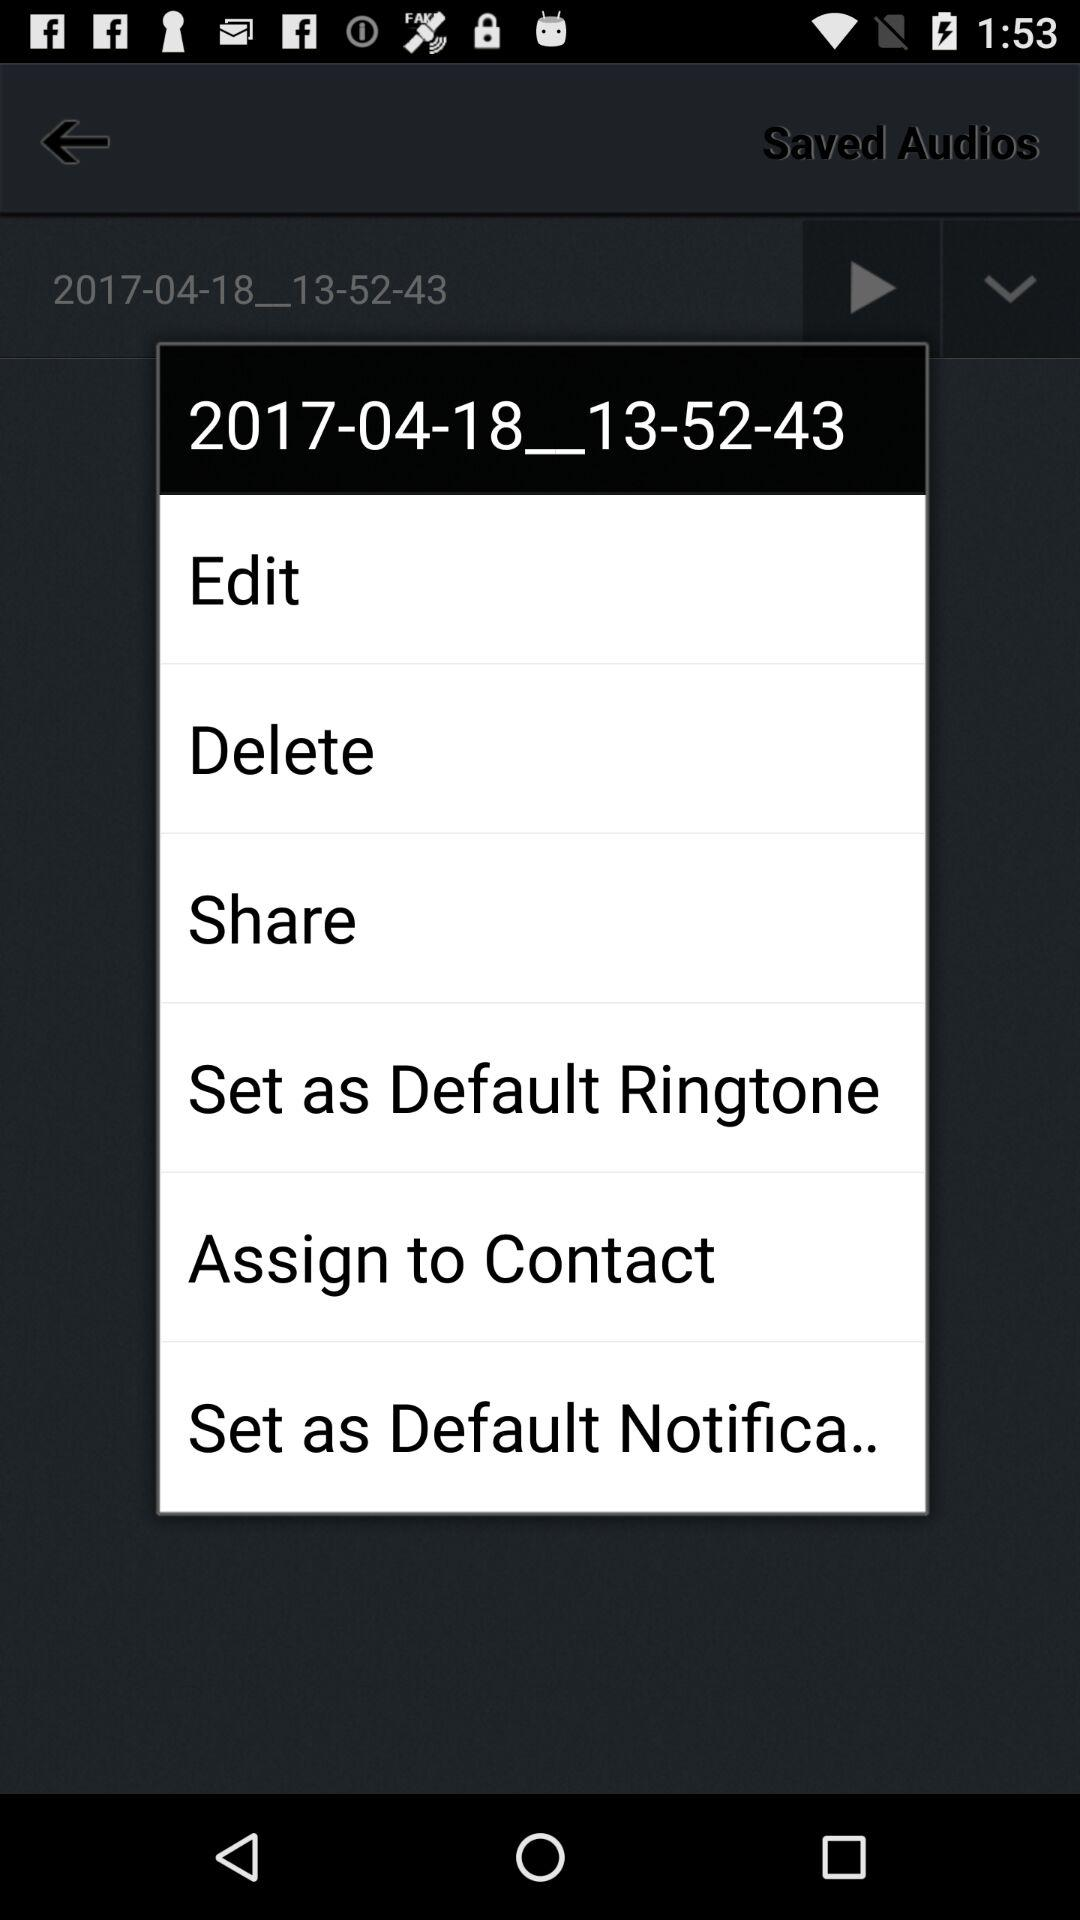What is the mentioned number?
When the provided information is insufficient, respond with <no answer>. <no answer> 